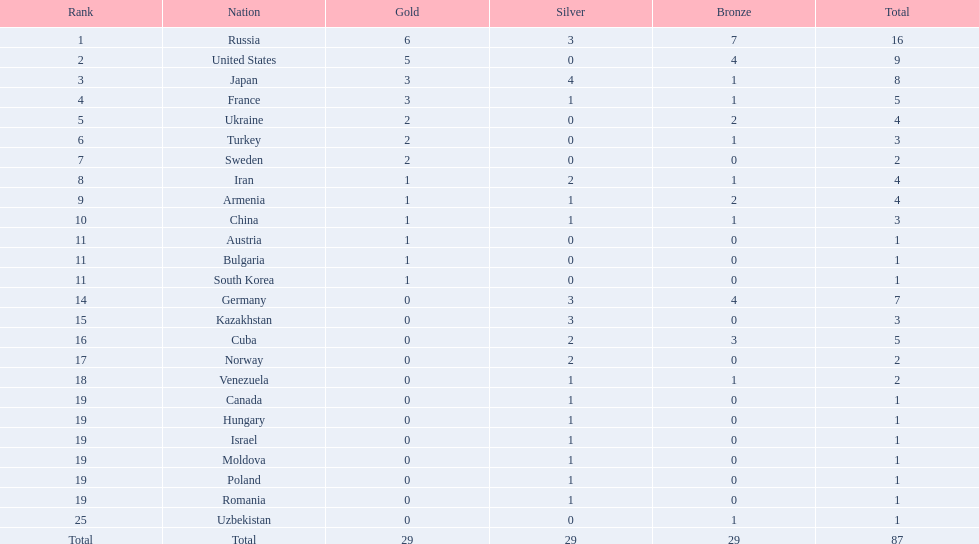What position did iran hold? 8. What position did germany hold? 14. Between iran and germany, which nation was not part of the top 10? Germany. 